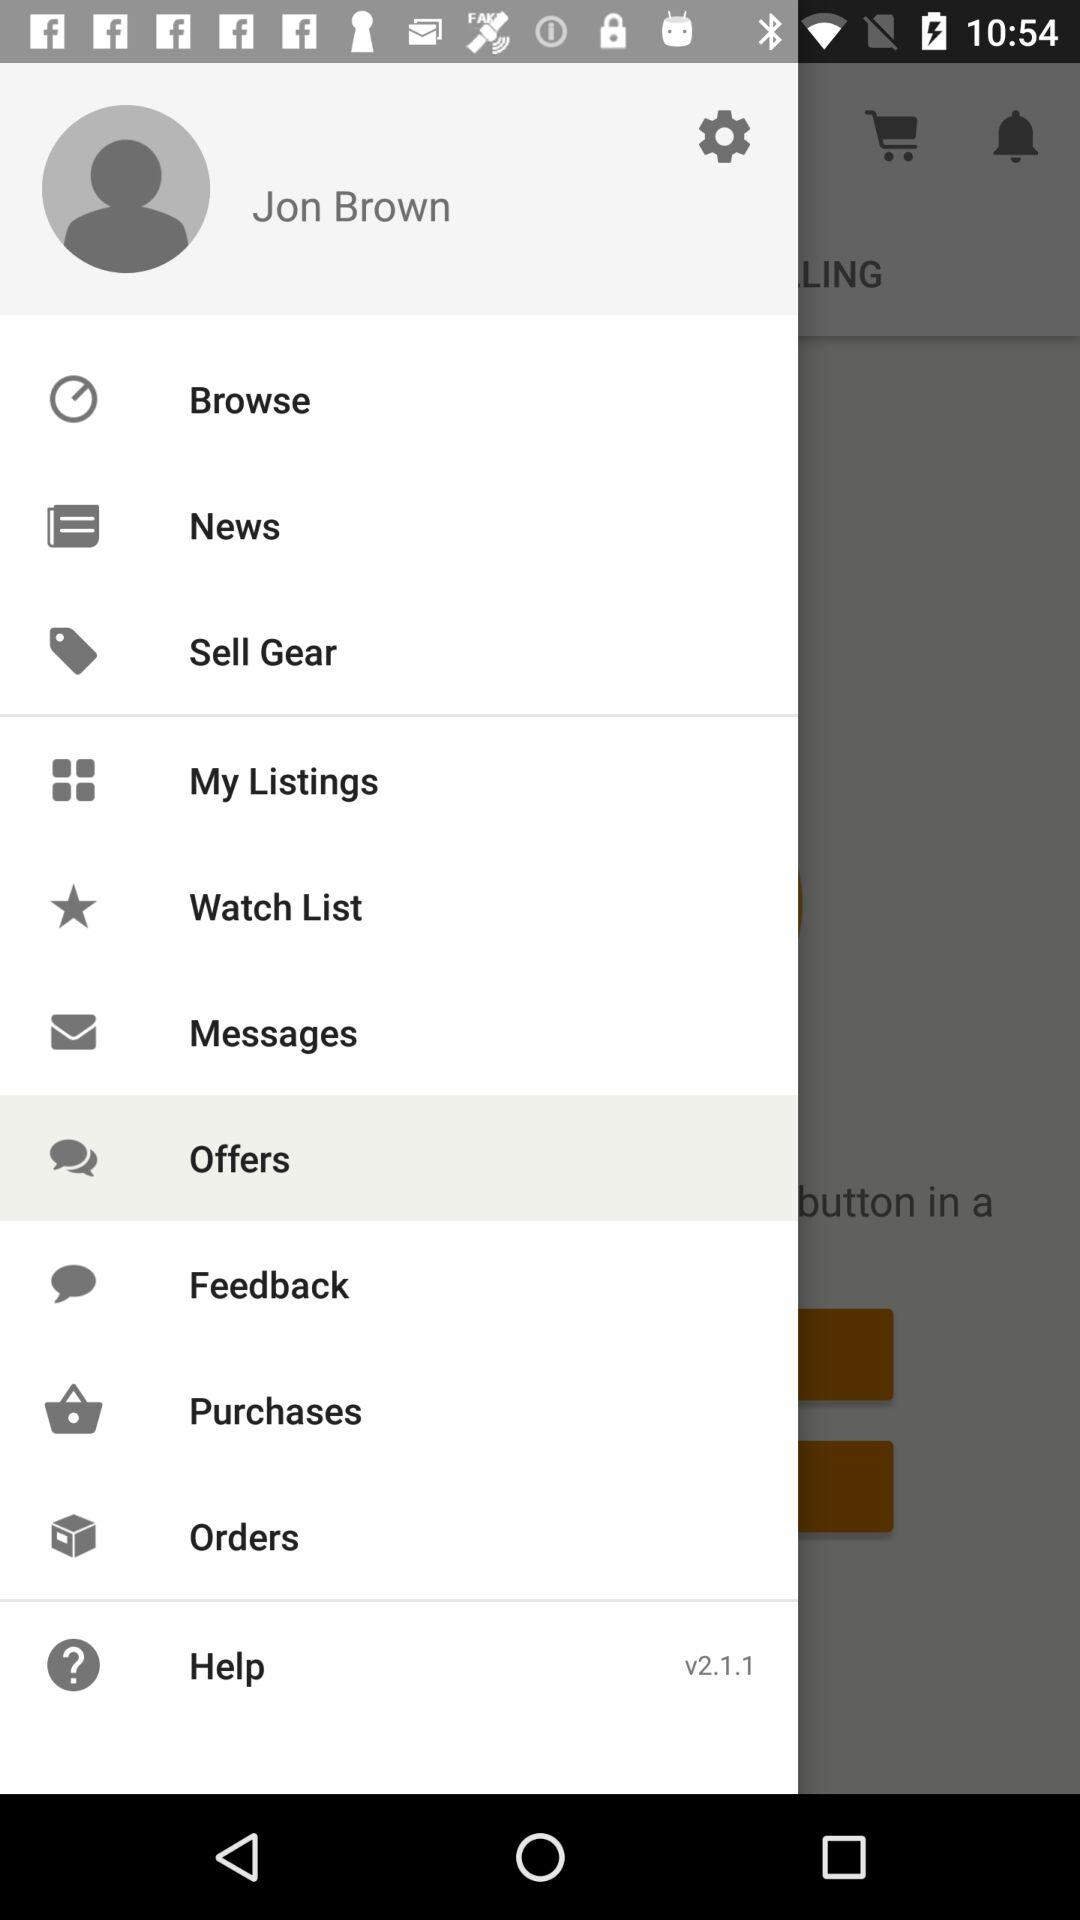Which option has been selected? The selected option is "Offers". 